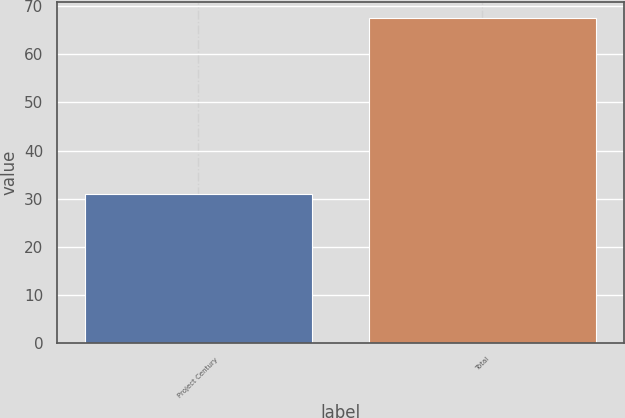Convert chart to OTSL. <chart><loc_0><loc_0><loc_500><loc_500><bar_chart><fcel>Project Century<fcel>Total<nl><fcel>30.9<fcel>67.6<nl></chart> 